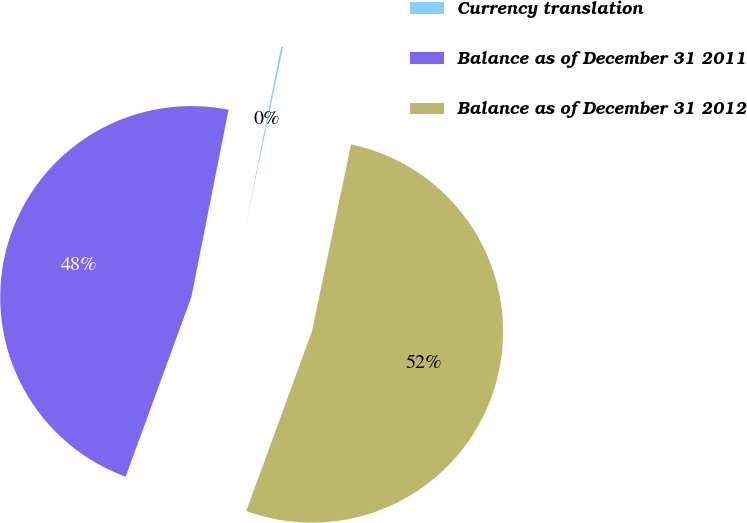<chart> <loc_0><loc_0><loc_500><loc_500><pie_chart><fcel>Currency translation<fcel>Balance as of December 31 2011<fcel>Balance as of December 31 2012<nl><fcel>0.16%<fcel>47.53%<fcel>52.3%<nl></chart> 